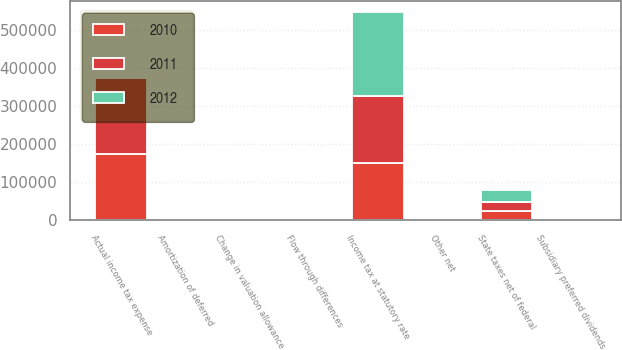<chart> <loc_0><loc_0><loc_500><loc_500><stacked_bar_chart><ecel><fcel>Income tax at statutory rate<fcel>State taxes net of federal<fcel>Change in valuation allowance<fcel>Flow through differences<fcel>Amortization of deferred<fcel>Subsidiary preferred dividends<fcel>Other net<fcel>Actual income tax expense<nl><fcel>2012<fcel>220940<fcel>32877<fcel>143<fcel>3032<fcel>1518<fcel>634<fcel>900<fcel>2807<nl><fcel>2011<fcel>176288<fcel>24027<fcel>160<fcel>2895<fcel>1542<fcel>668<fcel>3425<fcel>198751<nl><fcel>2010<fcel>150298<fcel>23241<fcel>533<fcel>2807<fcel>1561<fcel>675<fcel>575<fcel>174352<nl></chart> 